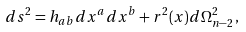<formula> <loc_0><loc_0><loc_500><loc_500>d s ^ { 2 } = h _ { a b } d x ^ { a } d x ^ { b } + r ^ { 2 } ( x ) d \Omega _ { n - 2 } ^ { 2 } \, ,</formula> 